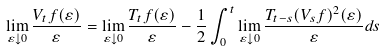Convert formula to latex. <formula><loc_0><loc_0><loc_500><loc_500>\lim _ { \varepsilon \downarrow 0 } \frac { V _ { t } f ( \varepsilon ) } { \varepsilon } = \lim _ { \varepsilon \downarrow 0 } \frac { T _ { t } f ( \varepsilon ) } { \varepsilon } - \frac { 1 } { 2 } \int _ { 0 } ^ { t } \lim _ { \varepsilon \downarrow 0 } \frac { T _ { t - s } ( V _ { s } f ) ^ { 2 } ( \varepsilon ) } { \varepsilon } d s</formula> 